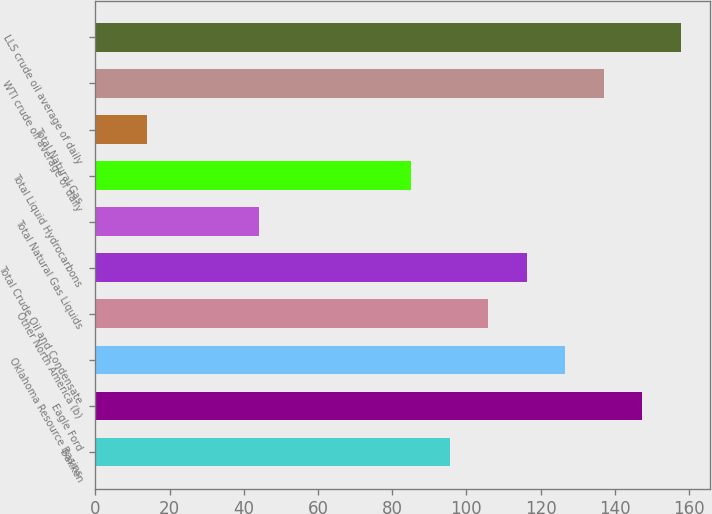<chart> <loc_0><loc_0><loc_500><loc_500><bar_chart><fcel>Bakken<fcel>Eagle Ford<fcel>Oklahoma Resource Basins<fcel>Other North America (b)<fcel>Total Crude Oil and Condensate<fcel>Total Natural Gas Liquids<fcel>Total Liquid Hydrocarbons<fcel>Total Natural Gas<fcel>WTI crude oil average of daily<fcel>LLS crude oil average of daily<nl><fcel>95.57<fcel>147.42<fcel>126.68<fcel>105.94<fcel>116.31<fcel>44.15<fcel>85.2<fcel>14.02<fcel>137.05<fcel>157.79<nl></chart> 